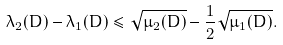Convert formula to latex. <formula><loc_0><loc_0><loc_500><loc_500>\lambda _ { 2 } ( D ) - \lambda _ { 1 } ( D ) \leq \sqrt { \mu _ { 2 } ( D ) } - { \frac { 1 } { 2 } } \sqrt { \mu _ { 1 } ( D ) } .</formula> 